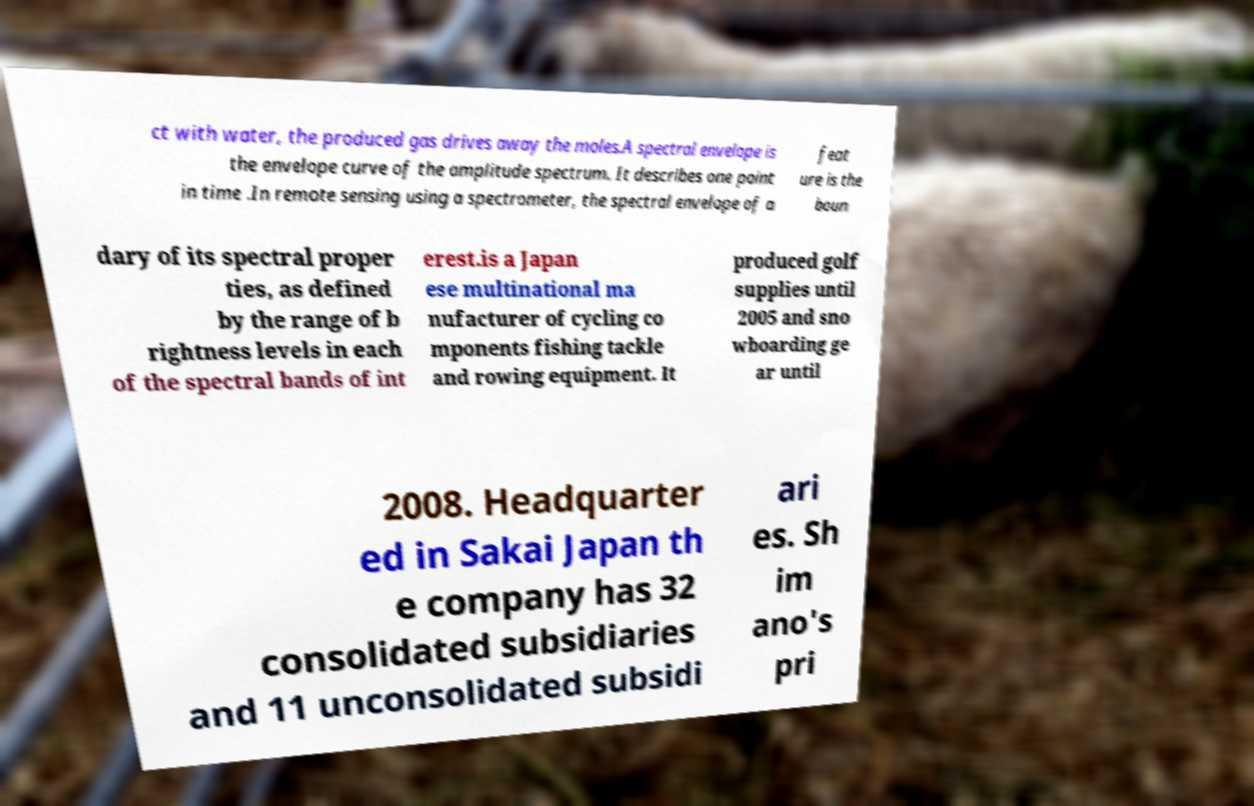For documentation purposes, I need the text within this image transcribed. Could you provide that? ct with water, the produced gas drives away the moles.A spectral envelope is the envelope curve of the amplitude spectrum. It describes one point in time .In remote sensing using a spectrometer, the spectral envelope of a feat ure is the boun dary of its spectral proper ties, as defined by the range of b rightness levels in each of the spectral bands of int erest.is a Japan ese multinational ma nufacturer of cycling co mponents fishing tackle and rowing equipment. It produced golf supplies until 2005 and sno wboarding ge ar until 2008. Headquarter ed in Sakai Japan th e company has 32 consolidated subsidiaries and 11 unconsolidated subsidi ari es. Sh im ano's pri 